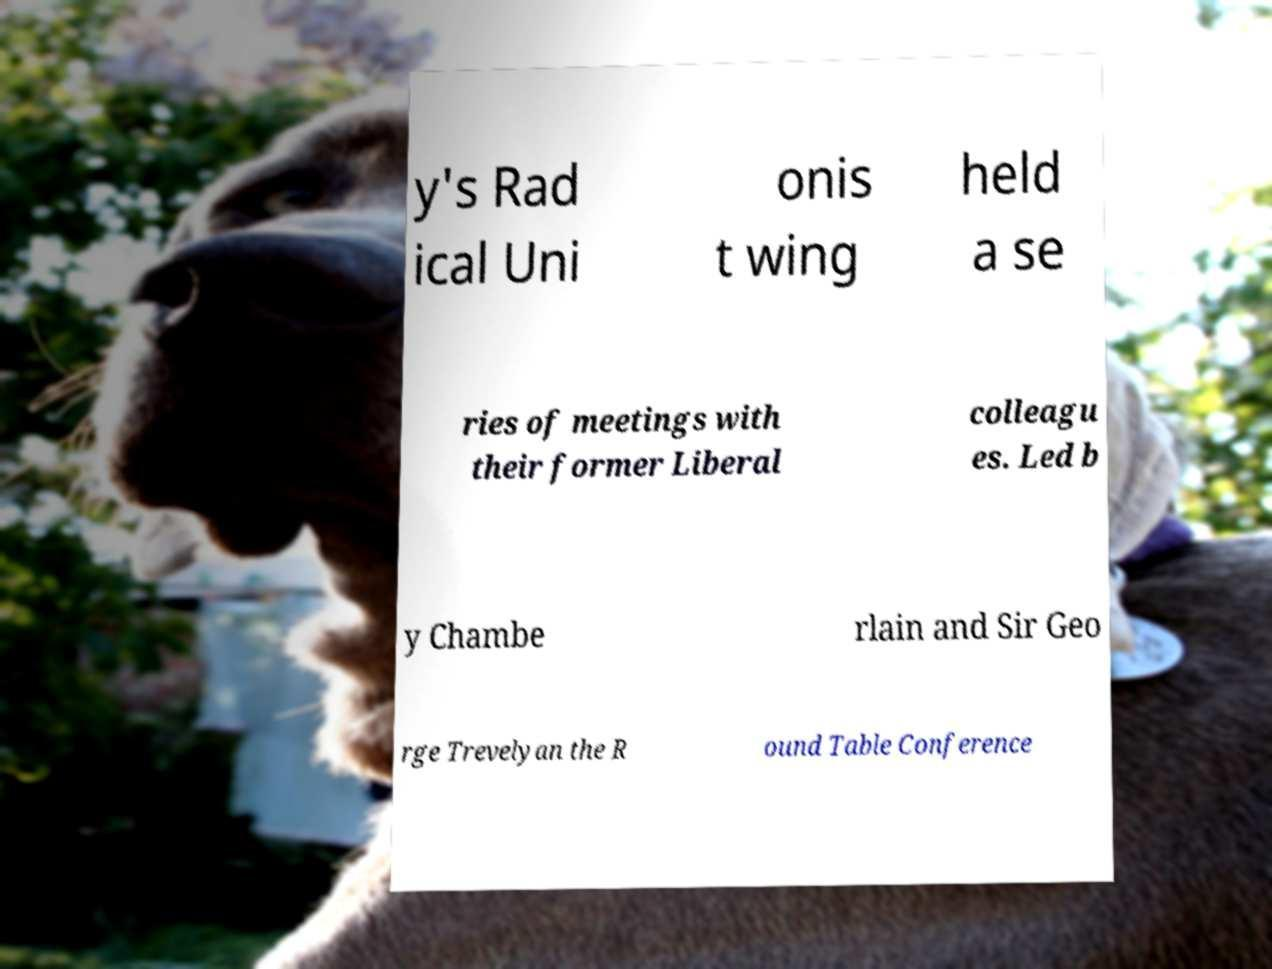Please read and relay the text visible in this image. What does it say? y's Rad ical Uni onis t wing held a se ries of meetings with their former Liberal colleagu es. Led b y Chambe rlain and Sir Geo rge Trevelyan the R ound Table Conference 